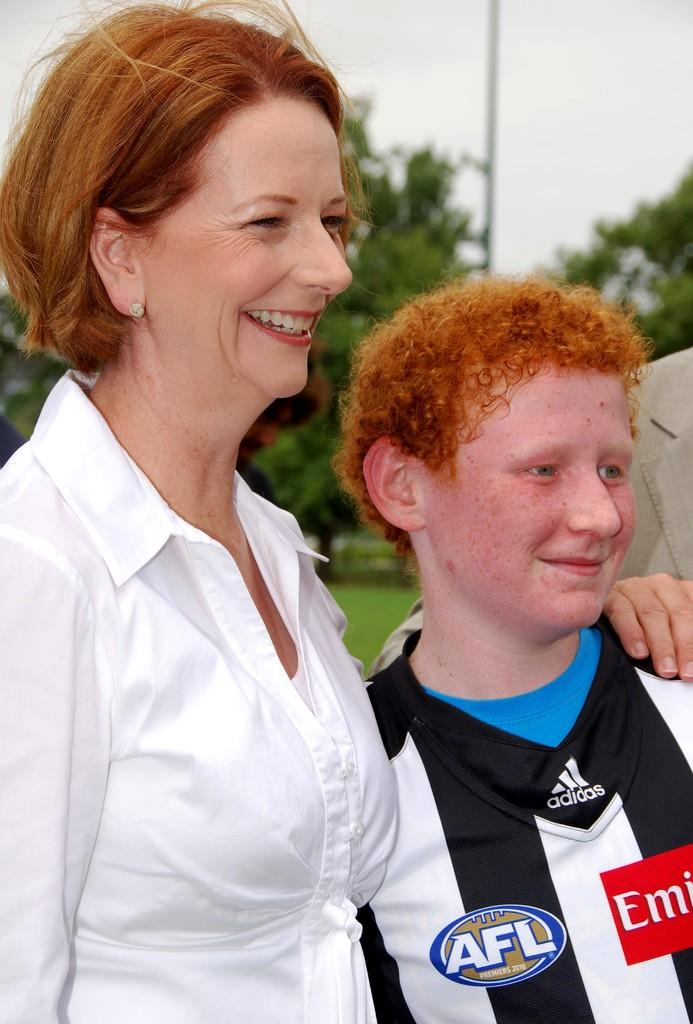<image>
Present a compact description of the photo's key features. A woman and red headed boy smiling with AFL on his shirt. 